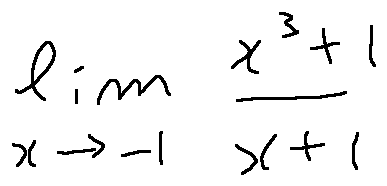Convert formula to latex. <formula><loc_0><loc_0><loc_500><loc_500>\lim \lim i t s _ { x \rightarrow - 1 } \frac { x ^ { 3 } + 1 } { x + 1 }</formula> 